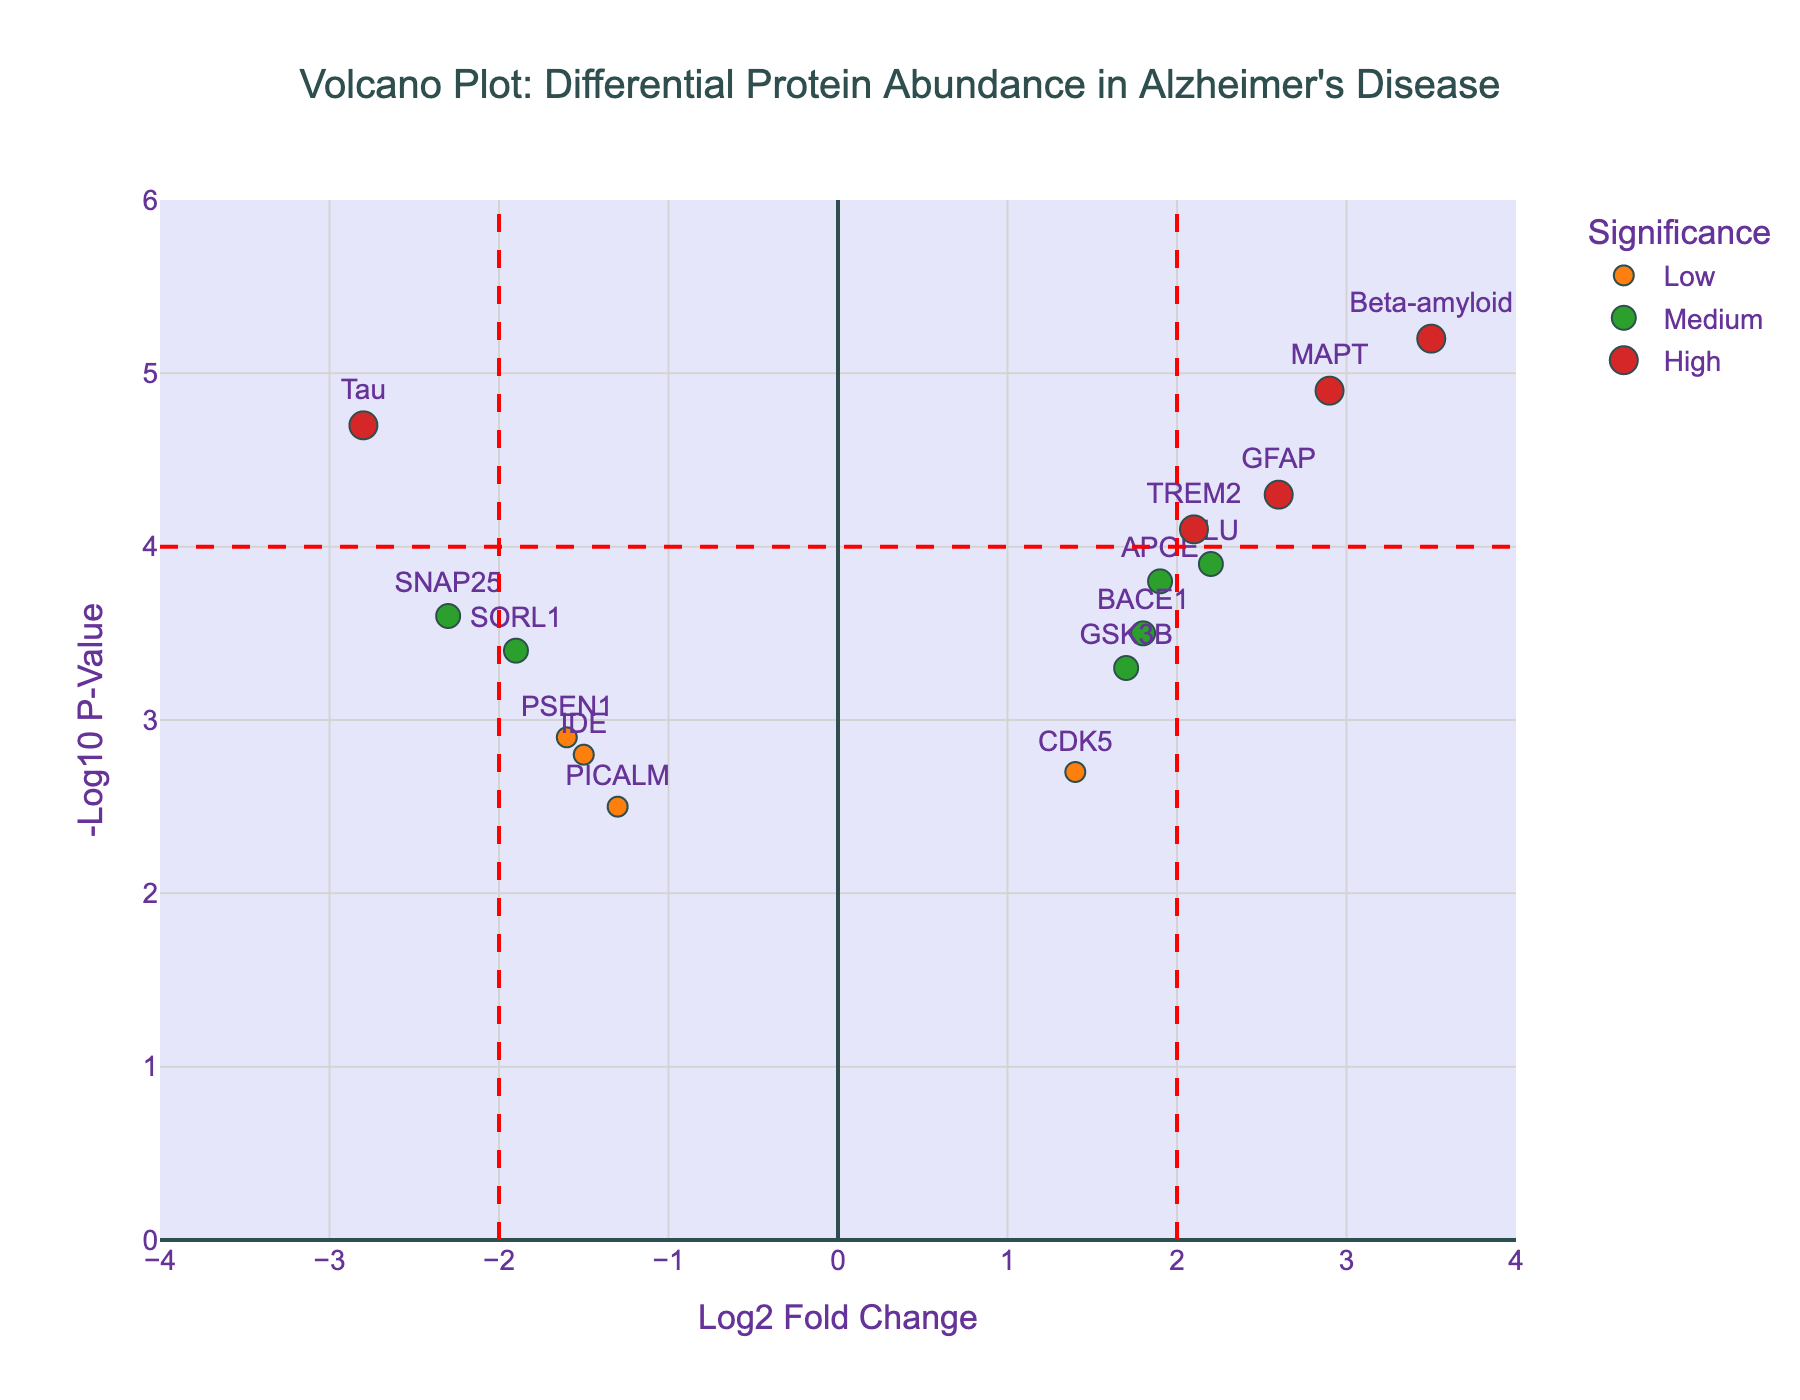What's the title of the figure? The title is usually placed prominently at the top of the figure. In this case, it reads "Volcano Plot: Differential Protein Abundance in Alzheimer's Disease."
Answer: "Volcano Plot: Differential Protein Abundance in Alzheimer's Disease" What are the x-axis and y-axis labels? The labels of the axes can usually be found along the horizontal and vertical edges of the plot. Here, the x-axis is labeled "Log2 Fold Change" and the y-axis is labeled "-Log10 P-Value."
Answer: x-axis: "Log2 Fold Change", y-axis: "-Log10 P-Value" Which protein has the highest -Log10 P-Value? By looking at the y-axis, the point at the highest position represents the highest -Log10 P-Value. The protein at the topmost position is "Beta-amyloid" with a -Log10 P-Value of 5.2.
Answer: Beta-amyloid Which proteins fall into the 'High' significance category and how can you tell? The 'High' significance category is indicated by being above the line y=4 and having Log2 Fold Change greater than 2 or less than -2. Proteins "Beta-amyloid," "Tau," and "MAPT" fall into this category.
Answer: Beta-amyloid, Tau, MAPT How many proteins have a Log2 Fold Change greater than 2? Proteins with a Log2 Fold Change greater than 2 are located to the right of the line x=2. By counting those points: "Beta-amyloid," "MAPT," and "GFAP."
Answer: 3 proteins Which protein has the lowest Log2 Fold Change? The lowest Log2 Fold Change is indicated by the farthest point on the left side of the x-axis. The protein in this position is "Tau" with a Log2 Fold Change of -2.8.
Answer: Tau Compare the Log2 Fold Change of Beta-amyloid and TREM2. Locate both proteins on the x-axis. "Beta-amyloid" at 3.5 and "TREM2" at 2.1. Comparing these values, "Beta-amyloid" has a higher Log2 Fold Change than "TREM2."
Answer: Beta-amyloid > TREM2 Which proteins are 'Not Significant' and why are they categorized as such? Proteins in the 'Not Significant' category neither exceed the -Log10 P-Value of 2 nor fall in Log2 Fold Change absolute values beyond 1. Proteins such as "CDK5," "PSEN1," "IDE," and "PICALM" fit these criteria.
Answer: CDK5, PSEN1, IDE, PICALM What indicates the threshold lines on the plot, and what is their significance? The threshold lines are horizontal and vertical red dashed lines at y=4 and x=±2. They signify proteins with significant changes in abundance (beyond these lines are considered 'High' significance).
Answer: Red dashed lines at y=4 and x=±2 How does SNAP25's protein abundance differ in Alzheimer’s disease compared to healthy controls? SNAP25 is to the left of the x-axis at -2.3 Log2 Fold Change, indicating decreased abundance in Alzheimer's patients compared to healthy controls.
Answer: Decreased abundance 